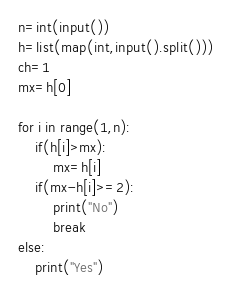<code> <loc_0><loc_0><loc_500><loc_500><_Python_>n=int(input())
h=list(map(int,input().split()))
ch=1
mx=h[0]

for i in range(1,n):
    if(h[i]>mx):
        mx=h[i]
    if(mx-h[i]>=2):
        print("No")
        break
else:
    print("Yes")</code> 